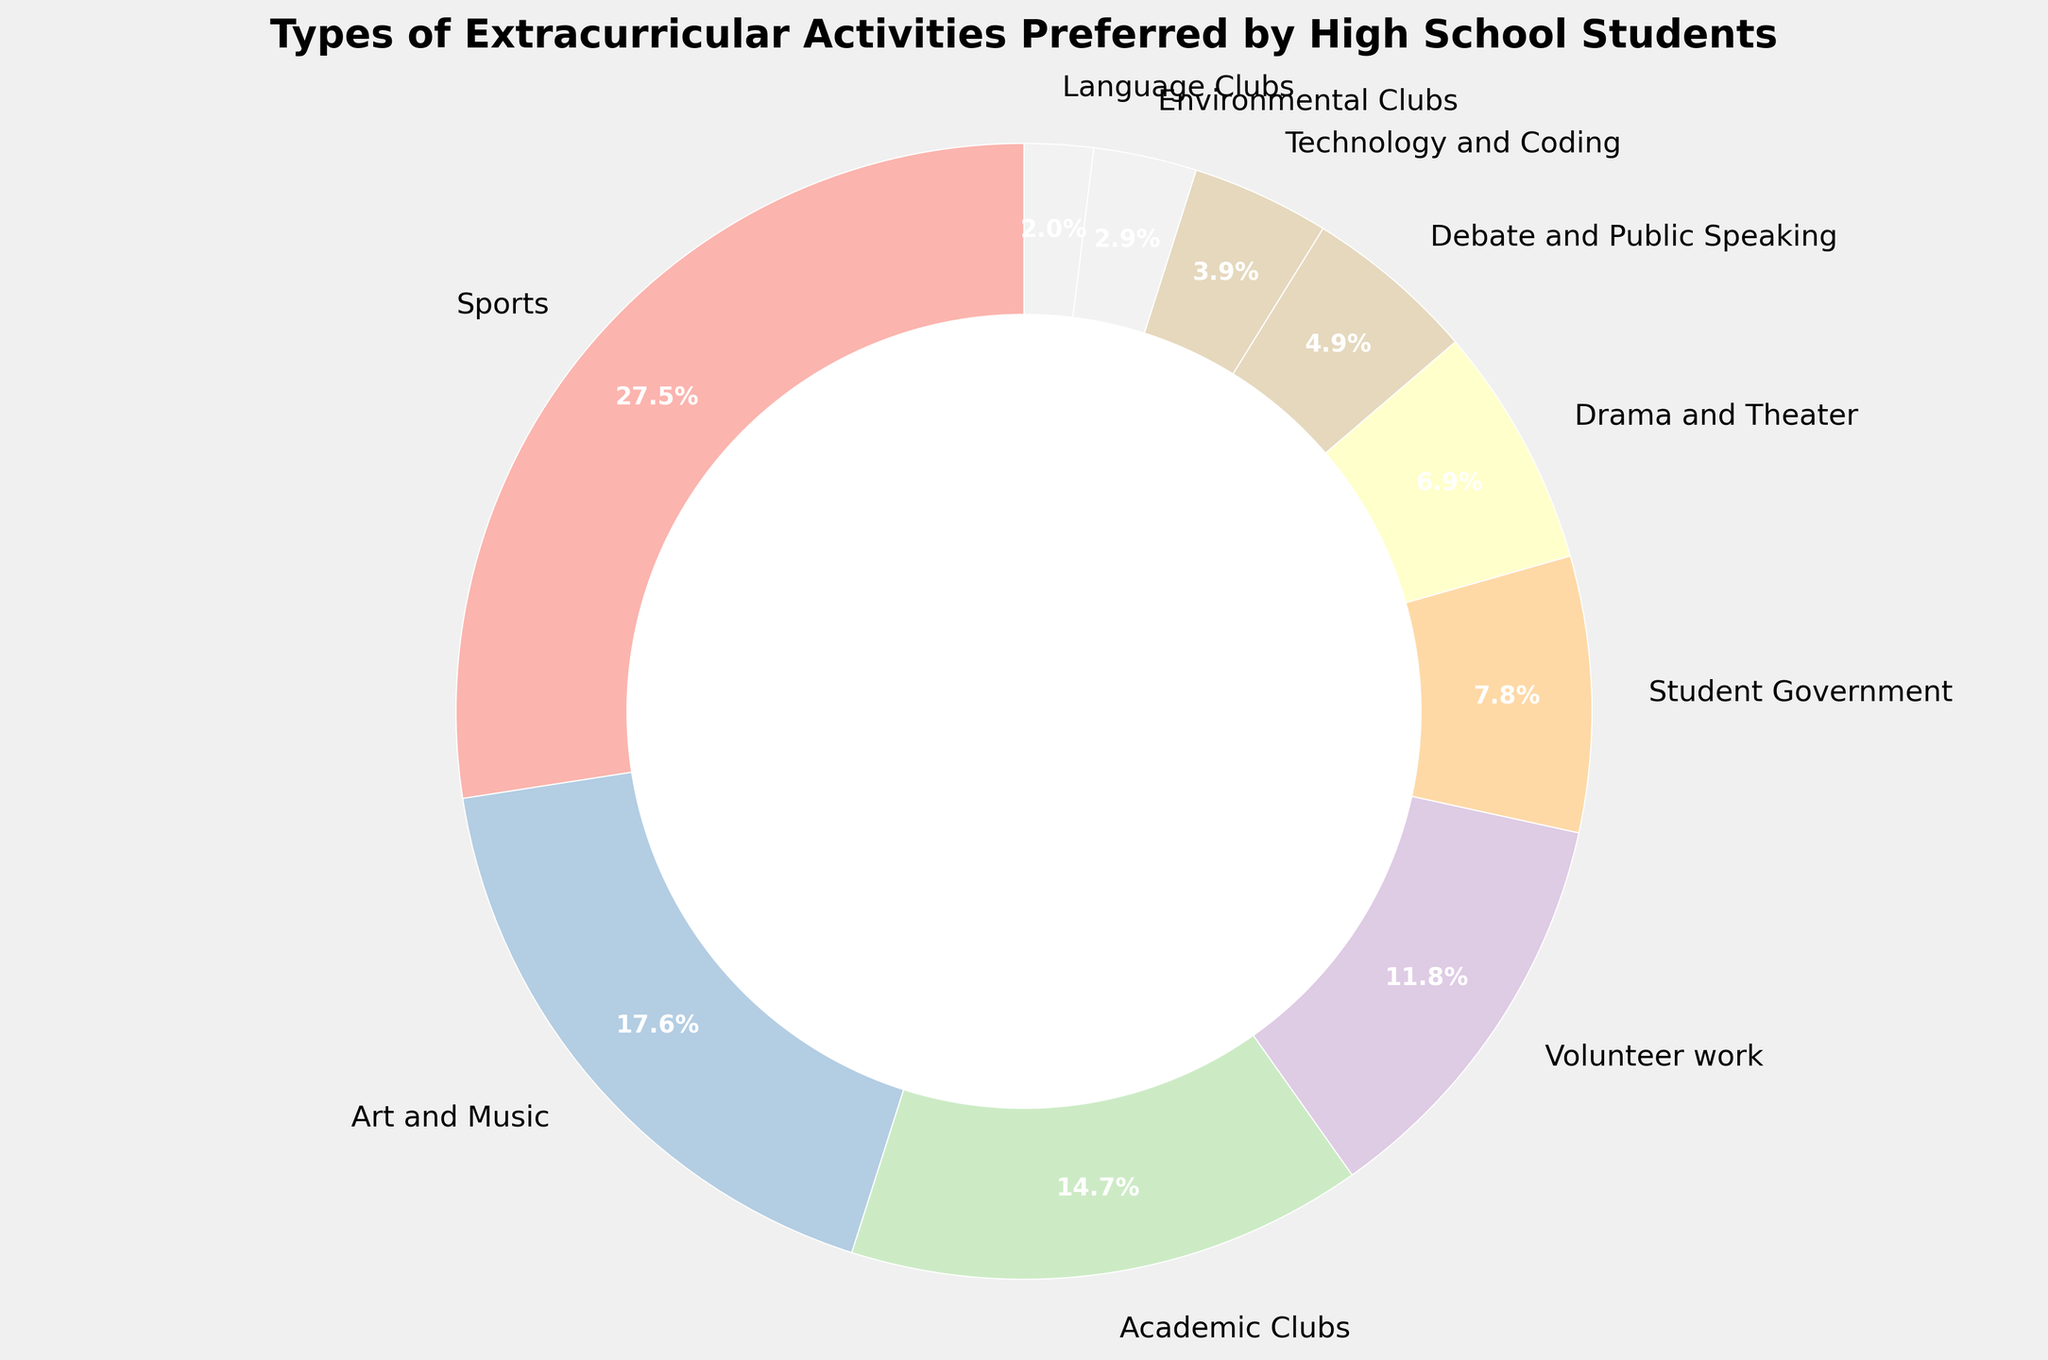What percentage of high school students prefer Sports activities? Locate the "Sports" section on the pie chart and refer to the percentage label.
Answer: 28% What is the combined percentage of students participating in Art and Music and Academic Clubs? Add the percentages for "Art and Music" and "Academic Clubs": 18% + 15%
Answer: 33% Which activity category has the lowest student preference, and what is its percentage? Find the smallest slice of the pie chart and read its label. "Language Clubs" has the lowest preference at 2%
Answer: Language Clubs, 2% Are there more students involved in Drama and Theater or in Technology and Coding? Compare the percentages for "Drama and Theater" (7%) and "Technology and Coding" (4%). 7% > 4%
Answer: Drama and Theater What is the total percentage of students involved in Volunteer Work, Student Government, and Debate and Public Speaking? Add the percentages for "Volunteer Work" (12%), "Student Government" (8%), and "Debate and Public Speaking" (5%): 12% + 8% + 5%
Answer: 25% Is the percentage of students in Environmental Clubs greater than or less than half of those in Academic Clubs? Compare the percentages of "Environmental Clubs" (3%) to half of "Academic Clubs" (15% / 2 = 7.5%). 3% < 7.5%
Answer: Less than Do more students prefer Sports or Art and Music? Compare the percentages for "Sports" (28%) and "Art and Music" (18%). 28% > 18%
Answer: Sports What's the percentage difference between the most and least preferred activities? Subtract the percentage of the least preferred activity ("Language Clubs" - 2%) from the most preferred activity ("Sports" - 28%): 28% - 2%
Answer: 26% How many categories have a preference percentage of less than 10%? Count the sections in the pie chart with percentages below 10%: "Student Government", "Drama and Theater", "Debate and Public Speaking", "Technology and Coding", "Environmental Clubs", and "Language Clubs".
Answer: 6 Is the percentage of students in Volunteer Work activities closer to those in Sports or Drama and Theater? Compare the percentage of "Volunteer Work" (12%) to both "Sports" (28%) and "Drama and Theater" (7%). The difference is 28% - 12% = 16% for Sports, and 12% - 7% = 5% for Drama and Theater; 12% is closer to 7%
Answer: Drama and Theater 